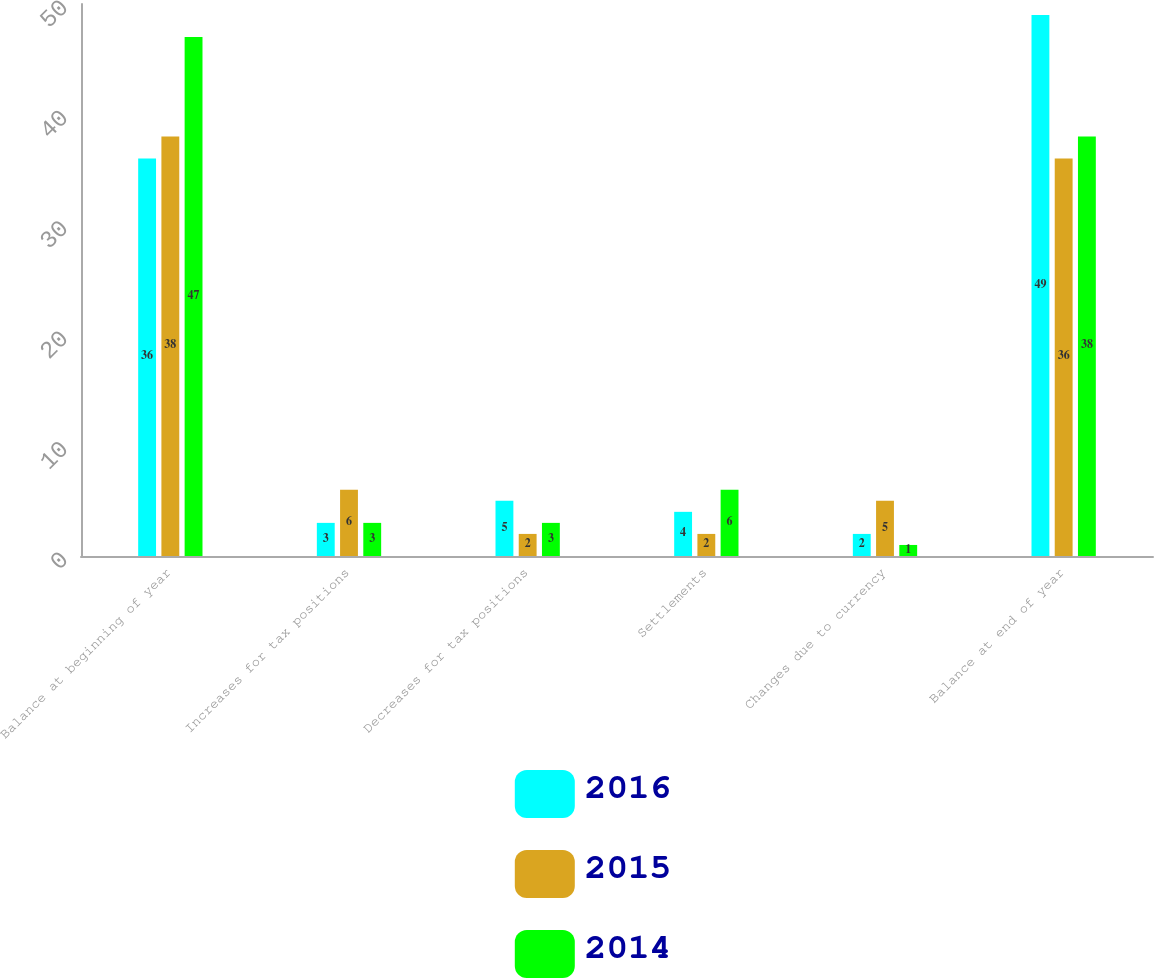Convert chart. <chart><loc_0><loc_0><loc_500><loc_500><stacked_bar_chart><ecel><fcel>Balance at beginning of year<fcel>Increases for tax positions<fcel>Decreases for tax positions<fcel>Settlements<fcel>Changes due to currency<fcel>Balance at end of year<nl><fcel>2016<fcel>36<fcel>3<fcel>5<fcel>4<fcel>2<fcel>49<nl><fcel>2015<fcel>38<fcel>6<fcel>2<fcel>2<fcel>5<fcel>36<nl><fcel>2014<fcel>47<fcel>3<fcel>3<fcel>6<fcel>1<fcel>38<nl></chart> 